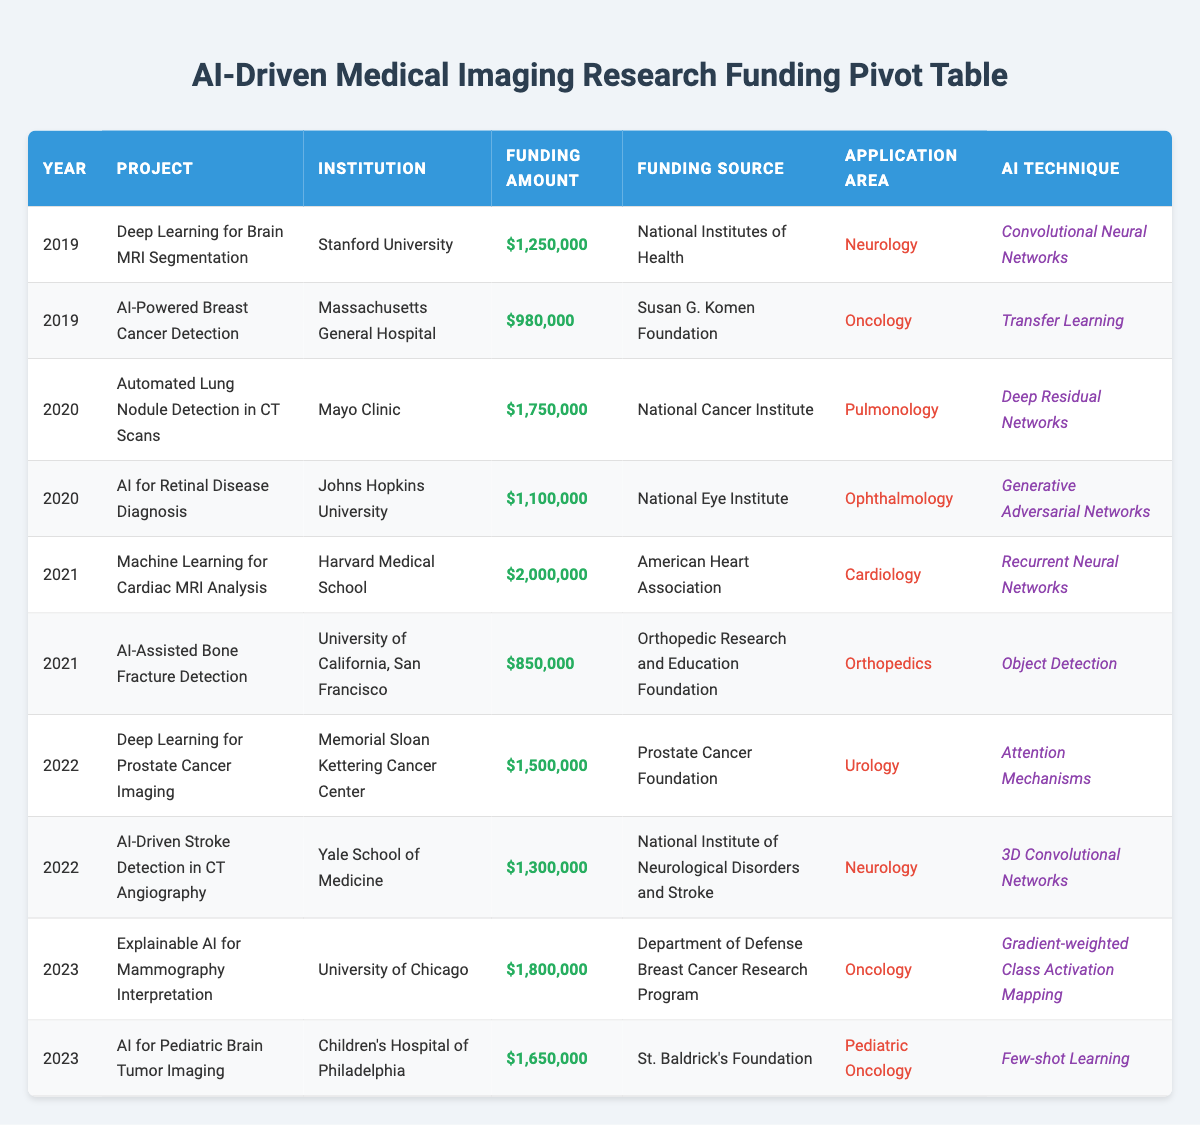What is the total funding amount allocated in 2021? The funding amounts for 2021 are $2,000,000 for "Machine Learning for Cardiac MRI Analysis" and $850,000 for "AI-Assisted Bone Fracture Detection." Adding these amounts gives $2,000,000 + $850,000 = $2,850,000.
Answer: $2,850,000 Which institution received funding for projects in both 2022 and 2023? In 2022, "AI-Driven Stroke Detection in CT Angiography" by Yale School of Medicine received funding, and in 2023, there is no project listed from Yale School of Medicine. Therefore, it did not receive funding projects in both years.
Answer: No What was the highest funding amount for a single project? The project "Machine Learning for Cardiac MRI Analysis" received the highest funding amount of $2,000,000 in 2021.
Answer: $2,000,000 How many projects received over $1,500,000 in funding? The projects that received funding over $1,500,000 are: "Automated Lung Nodule Detection in CT Scans" ($1,750,000 in 2020), "Machine Learning for Cardiac MRI Analysis" ($2,000,000 in 2021), and "Explainable AI for Mammography Interpretation" ($1,800,000 in 2023). That is a total of 3 projects.
Answer: 3 Is there a project funded by the National Institutes of Health in 2019? Yes, the project "Deep Learning for Brain MRI Segmentation" received funding from the National Institutes of Health in 2019.
Answer: Yes What is the average funding amount for projects in 2020? The funding amounts for projects in 2020 are $1,750,000 for "Automated Lung Nodule Detection in CT Scans" and $1,100,000 for "AI for Retinal Disease Diagnosis." The total funding is $2,850,000 for 2 projects. The average is $2,850,000 / 2 = $1,425,000.
Answer: $1,425,000 How many projects focused on Neurology did not exceed $1,000,000 in funding? The only project in Neurology is "AI-Driven Stroke Detection in CT Angiography" which received $1,300,000 and the "Deep Learning for Brain MRI Segmentation" project which received $1,250,000. Both projects exceeded $1,000,000.
Answer: 0 What is the total funding associated with the projects in Oncology over the past 5 years? The projects in Oncology are "AI-Powered Breast Cancer Detection" ($980,000 in 2019), "Explainable AI for Mammography Interpretation" ($1,800,000 in 2023). Adding these amounts gives $980,000 + $1,800,000 = $2,780,000 total funding.
Answer: $2,780,000 